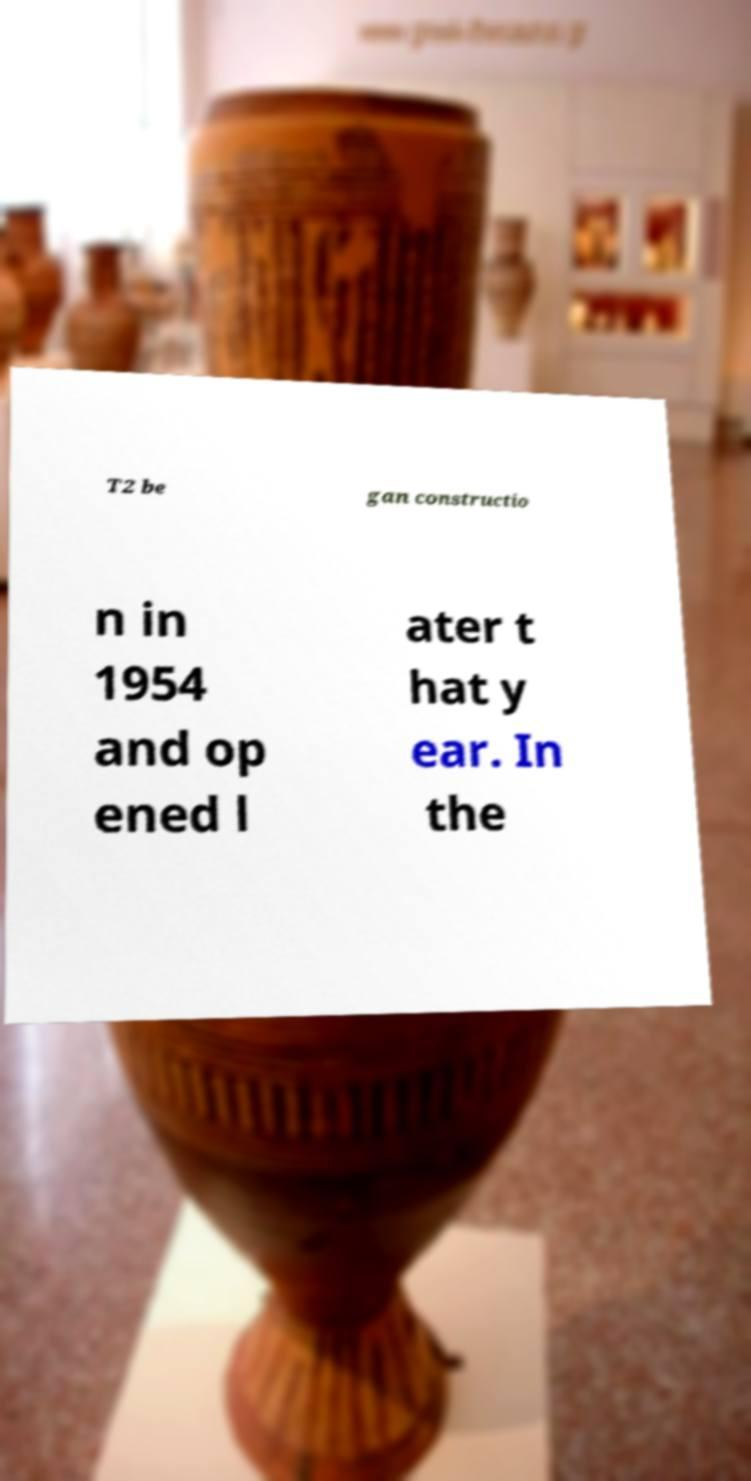Could you assist in decoding the text presented in this image and type it out clearly? T2 be gan constructio n in 1954 and op ened l ater t hat y ear. In the 